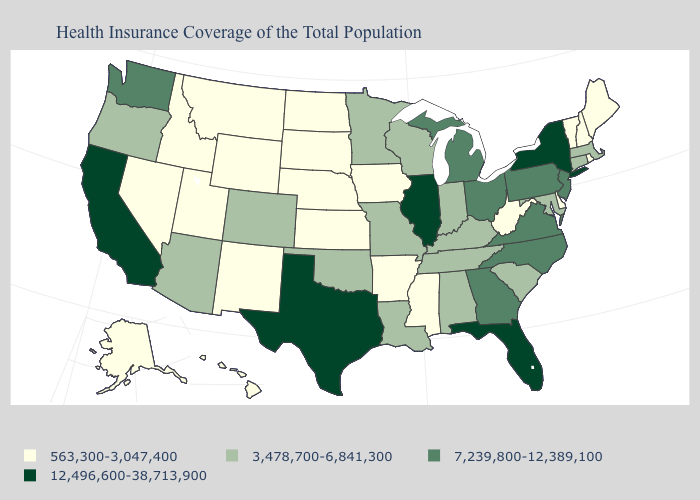What is the value of Oklahoma?
Answer briefly. 3,478,700-6,841,300. Name the states that have a value in the range 12,496,600-38,713,900?
Be succinct. California, Florida, Illinois, New York, Texas. Name the states that have a value in the range 563,300-3,047,400?
Short answer required. Alaska, Arkansas, Delaware, Hawaii, Idaho, Iowa, Kansas, Maine, Mississippi, Montana, Nebraska, Nevada, New Hampshire, New Mexico, North Dakota, Rhode Island, South Dakota, Utah, Vermont, West Virginia, Wyoming. What is the value of New Jersey?
Quick response, please. 7,239,800-12,389,100. Does California have the highest value in the USA?
Write a very short answer. Yes. Which states have the lowest value in the USA?
Give a very brief answer. Alaska, Arkansas, Delaware, Hawaii, Idaho, Iowa, Kansas, Maine, Mississippi, Montana, Nebraska, Nevada, New Hampshire, New Mexico, North Dakota, Rhode Island, South Dakota, Utah, Vermont, West Virginia, Wyoming. Does New Hampshire have the lowest value in the Northeast?
Quick response, please. Yes. Does the first symbol in the legend represent the smallest category?
Quick response, please. Yes. Name the states that have a value in the range 12,496,600-38,713,900?
Be succinct. California, Florida, Illinois, New York, Texas. Does Connecticut have the lowest value in the Northeast?
Give a very brief answer. No. Does Oklahoma have the same value as Montana?
Answer briefly. No. Does Nebraska have a lower value than Connecticut?
Give a very brief answer. Yes. What is the value of Missouri?
Quick response, please. 3,478,700-6,841,300. Name the states that have a value in the range 7,239,800-12,389,100?
Quick response, please. Georgia, Michigan, New Jersey, North Carolina, Ohio, Pennsylvania, Virginia, Washington. 